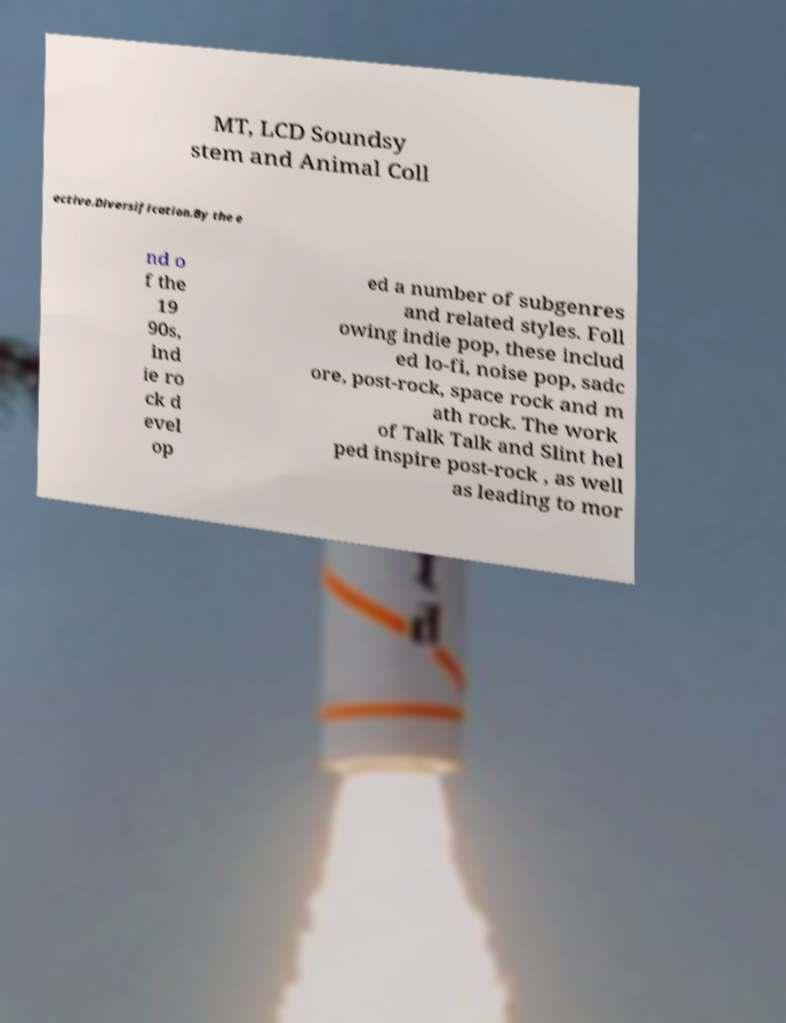Please read and relay the text visible in this image. What does it say? MT, LCD Soundsy stem and Animal Coll ective.Diversification.By the e nd o f the 19 90s, ind ie ro ck d evel op ed a number of subgenres and related styles. Foll owing indie pop, these includ ed lo-fi, noise pop, sadc ore, post-rock, space rock and m ath rock. The work of Talk Talk and Slint hel ped inspire post-rock , as well as leading to mor 